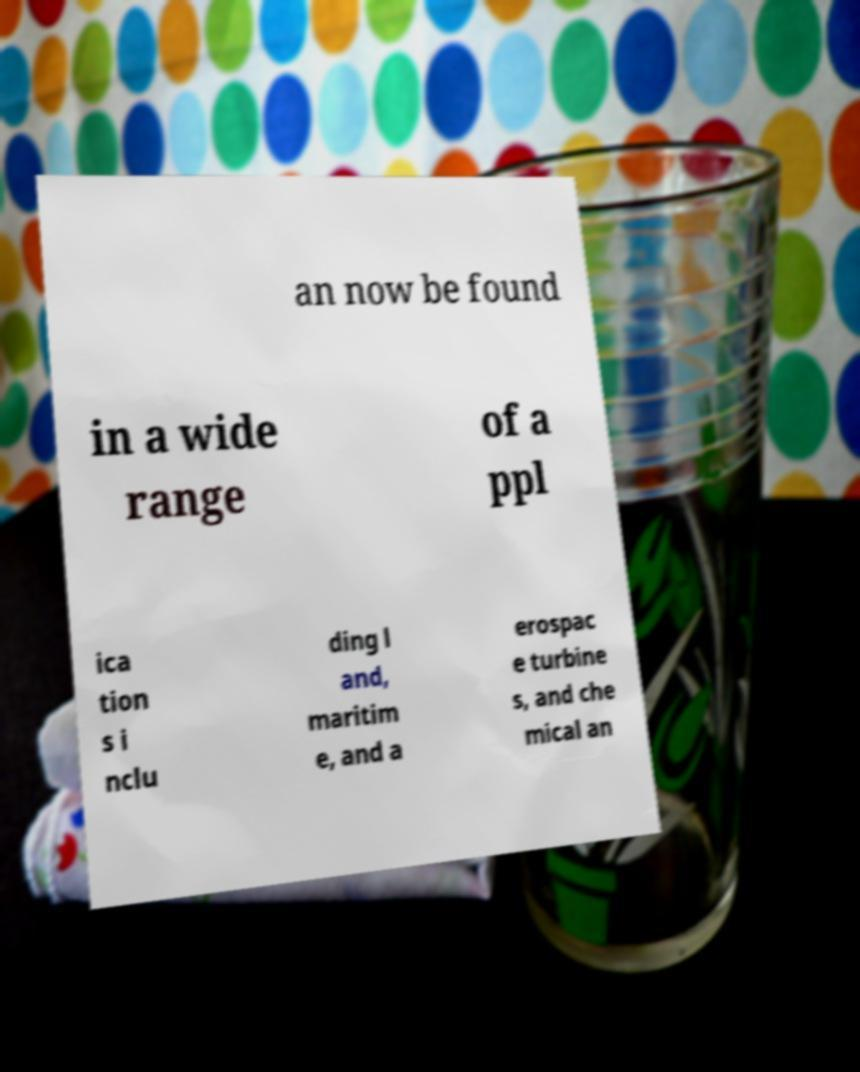Please read and relay the text visible in this image. What does it say? an now be found in a wide range of a ppl ica tion s i nclu ding l and, maritim e, and a erospac e turbine s, and che mical an 